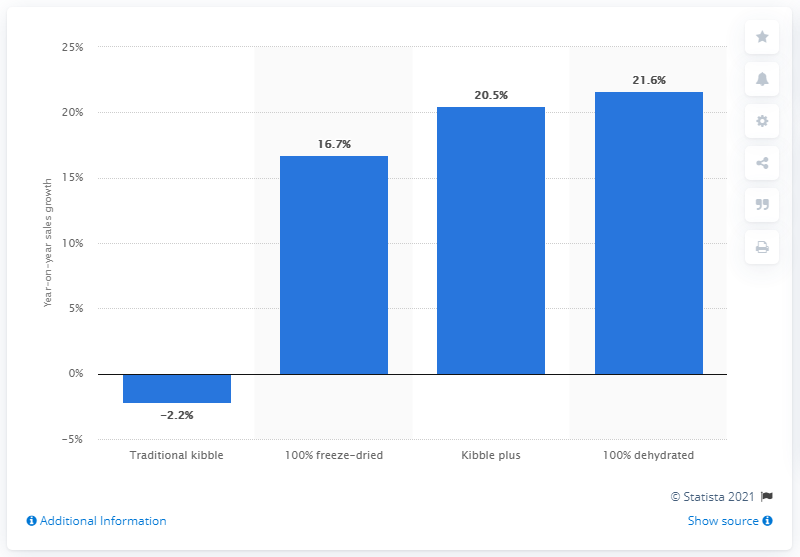Identify some key points in this picture. Sales of 100% dehydrated kibble increased by 21.6% between 2018 and 2019. Sales of 100% freeze-dried kibble increased by 16.7% between 2018 and 2019. 